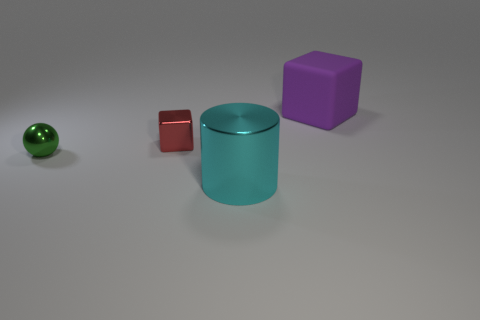Are there any other things that are the same material as the large purple thing?
Give a very brief answer. No. There is a thing to the right of the big object in front of the metal block; what size is it?
Ensure brevity in your answer.  Large. There is a cube that is left of the big thing that is in front of the block that is in front of the purple block; how big is it?
Your answer should be compact. Small. Do the object to the left of the tiny metallic cube and the small object that is on the right side of the green ball have the same shape?
Your answer should be very brief. No. What number of other things are there of the same color as the large cylinder?
Your response must be concise. 0. There is a object behind the red object; is it the same size as the small red block?
Your response must be concise. No. Is the material of the small thing that is to the right of the metallic ball the same as the cube right of the cyan cylinder?
Your answer should be compact. No. Is there a purple object that has the same size as the red shiny block?
Ensure brevity in your answer.  No. There is a large object in front of the small metal block that is on the left side of the metal thing that is in front of the small green shiny sphere; what shape is it?
Provide a short and direct response. Cylinder. Is the number of green metal spheres that are in front of the purple rubber cube greater than the number of small cyan shiny balls?
Keep it short and to the point. Yes. 